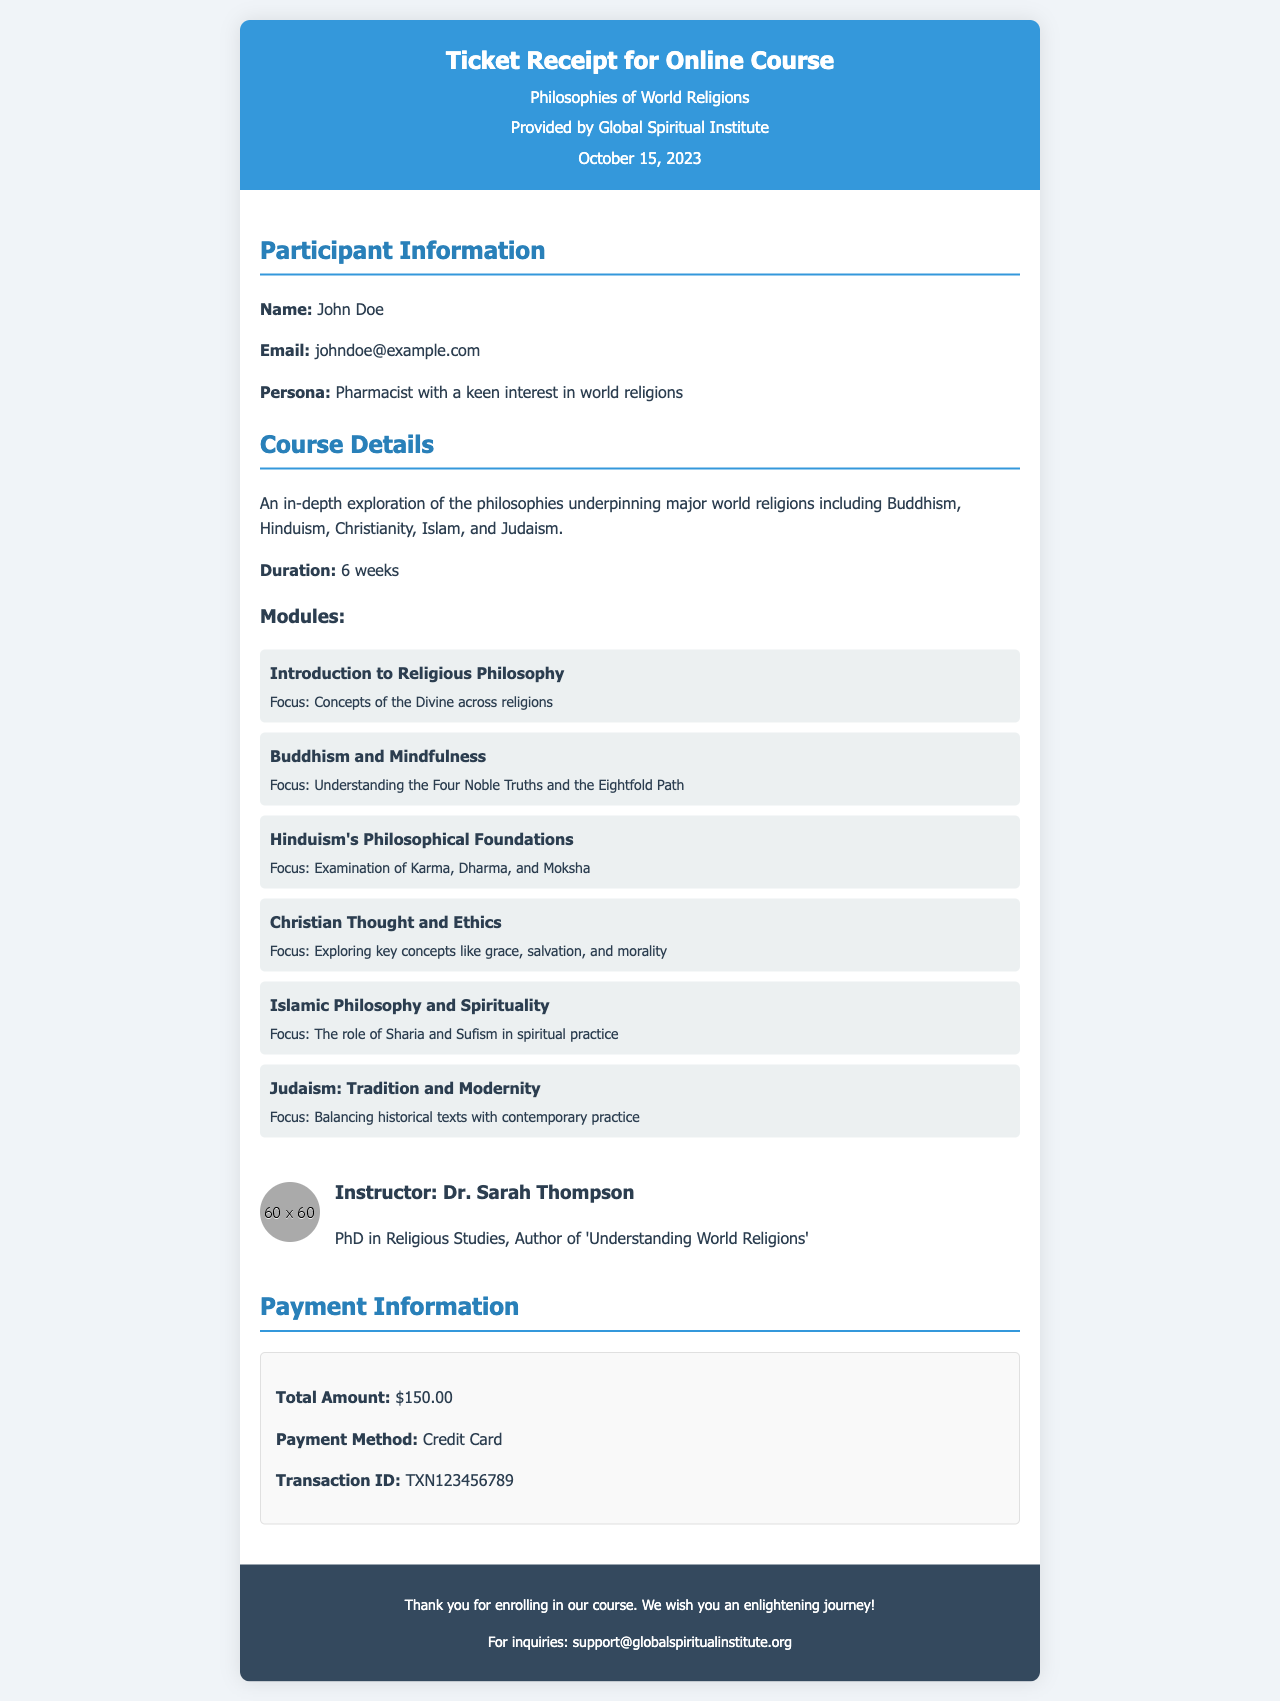what is the title of the course? The title of the course is provided in the header of the receipt.
Answer: Philosophies of World Religions who is the instructor? The instructor's name is mentioned along with their qualification and expertise in the document.
Answer: Dr. Sarah Thompson what is the total amount of the course? The total amount for the course is specified in the payment information section of the receipt.
Answer: $150.00 how many weeks does the course last? The duration of the course is explicitly stated in the course details section.
Answer: 6 weeks what focus area is covered in the "Hinduism's Philosophical Foundations" module? The focus area for this module is listed under its description in the receipt.
Answer: Examination of Karma, Dharma, and Moksha what is the transaction ID? The transaction ID is included in the payment information section of the receipt.
Answer: TXN123456789 which organization provided the course? The organization offering the course is mentioned in the header section of the receipt.
Answer: Global Spiritual Institute what is the email address for inquiries? The email address for reaching out about the course is provided in the footer of the receipt.
Answer: support@globalspiritualinstitute.org what is the main focus of the course? The main focus of the course is described in the course details section.
Answer: An in-depth exploration of the philosophies underpinning major world religions 